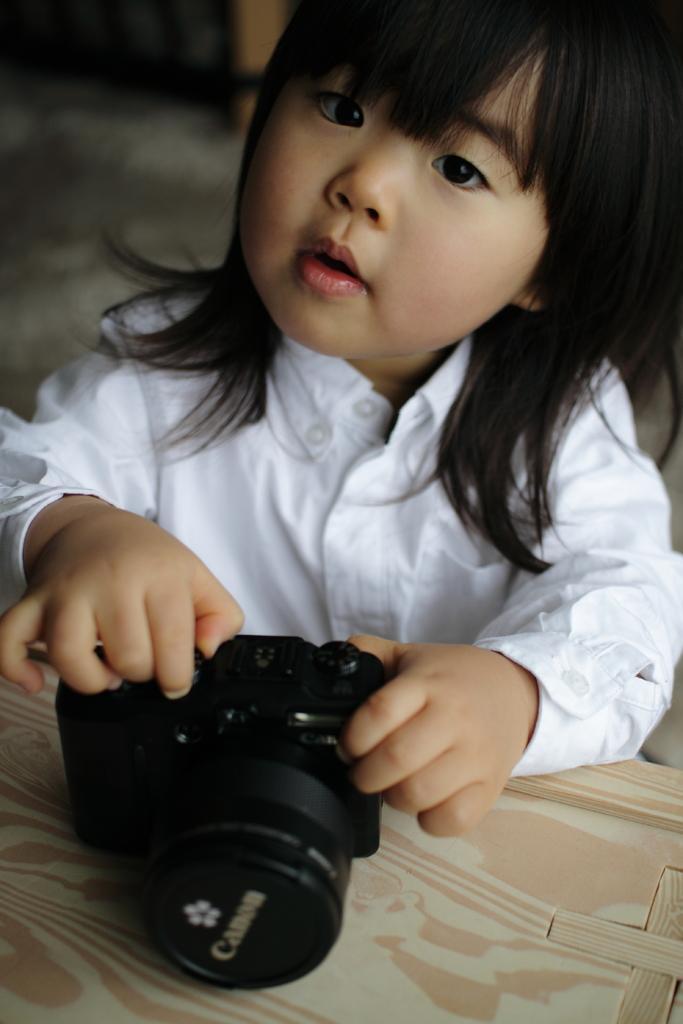Describe this image in one or two sentences. A girl is holding a camera and camera is placed on a table. And girl is wearing a white shirt. 